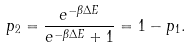<formula> <loc_0><loc_0><loc_500><loc_500>p _ { 2 } = \frac { e ^ { - \beta \Delta E } } { e ^ { - \beta \Delta E } + 1 } = 1 - p _ { 1 } .</formula> 